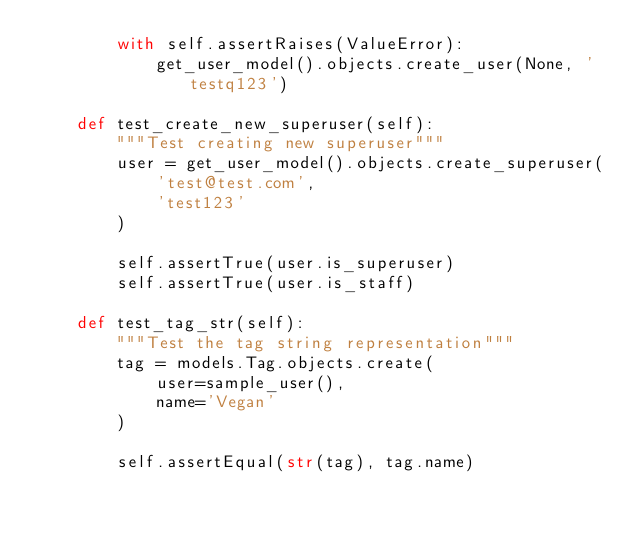Convert code to text. <code><loc_0><loc_0><loc_500><loc_500><_Python_>        with self.assertRaises(ValueError):
            get_user_model().objects.create_user(None, 'testq123')

    def test_create_new_superuser(self):
        """Test creating new superuser"""
        user = get_user_model().objects.create_superuser(
            'test@test.com',
            'test123'
        )

        self.assertTrue(user.is_superuser)
        self.assertTrue(user.is_staff)

    def test_tag_str(self):
        """Test the tag string representation"""
        tag = models.Tag.objects.create(
            user=sample_user(),
            name='Vegan'
        )

        self.assertEqual(str(tag), tag.name)
</code> 